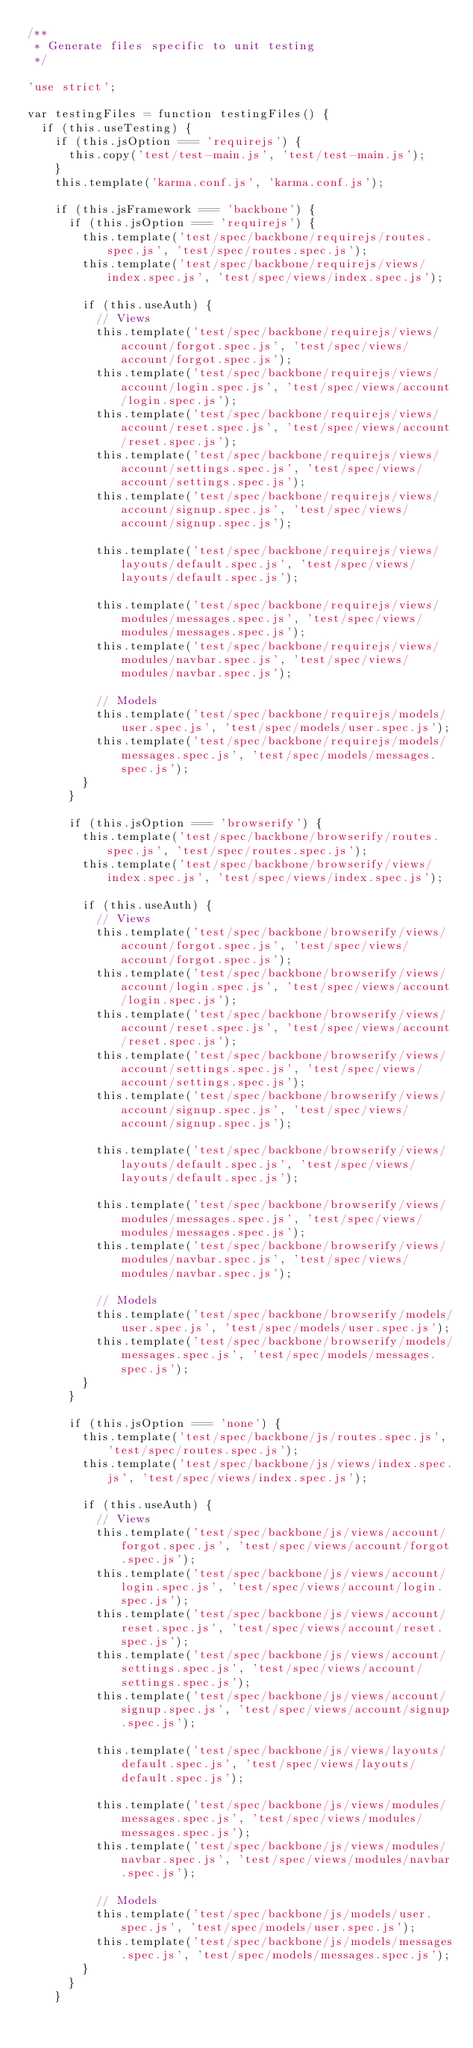<code> <loc_0><loc_0><loc_500><loc_500><_JavaScript_>/**
 * Generate files specific to unit testing
 */

'use strict';

var testingFiles = function testingFiles() {
  if (this.useTesting) {
    if (this.jsOption === 'requirejs') {
      this.copy('test/test-main.js', 'test/test-main.js');
    }
    this.template('karma.conf.js', 'karma.conf.js');

    if (this.jsFramework === 'backbone') {
      if (this.jsOption === 'requirejs') {
        this.template('test/spec/backbone/requirejs/routes.spec.js', 'test/spec/routes.spec.js');
        this.template('test/spec/backbone/requirejs/views/index.spec.js', 'test/spec/views/index.spec.js');

        if (this.useAuth) {
          // Views
          this.template('test/spec/backbone/requirejs/views/account/forgot.spec.js', 'test/spec/views/account/forgot.spec.js');
          this.template('test/spec/backbone/requirejs/views/account/login.spec.js', 'test/spec/views/account/login.spec.js');
          this.template('test/spec/backbone/requirejs/views/account/reset.spec.js', 'test/spec/views/account/reset.spec.js');
          this.template('test/spec/backbone/requirejs/views/account/settings.spec.js', 'test/spec/views/account/settings.spec.js');
          this.template('test/spec/backbone/requirejs/views/account/signup.spec.js', 'test/spec/views/account/signup.spec.js');

          this.template('test/spec/backbone/requirejs/views/layouts/default.spec.js', 'test/spec/views/layouts/default.spec.js');

          this.template('test/spec/backbone/requirejs/views/modules/messages.spec.js', 'test/spec/views/modules/messages.spec.js');
          this.template('test/spec/backbone/requirejs/views/modules/navbar.spec.js', 'test/spec/views/modules/navbar.spec.js');

          // Models
          this.template('test/spec/backbone/requirejs/models/user.spec.js', 'test/spec/models/user.spec.js');
          this.template('test/spec/backbone/requirejs/models/messages.spec.js', 'test/spec/models/messages.spec.js');
        }
      }

      if (this.jsOption === 'browserify') {
        this.template('test/spec/backbone/browserify/routes.spec.js', 'test/spec/routes.spec.js');
        this.template('test/spec/backbone/browserify/views/index.spec.js', 'test/spec/views/index.spec.js');

        if (this.useAuth) {
          // Views
          this.template('test/spec/backbone/browserify/views/account/forgot.spec.js', 'test/spec/views/account/forgot.spec.js');
          this.template('test/spec/backbone/browserify/views/account/login.spec.js', 'test/spec/views/account/login.spec.js');
          this.template('test/spec/backbone/browserify/views/account/reset.spec.js', 'test/spec/views/account/reset.spec.js');
          this.template('test/spec/backbone/browserify/views/account/settings.spec.js', 'test/spec/views/account/settings.spec.js');
          this.template('test/spec/backbone/browserify/views/account/signup.spec.js', 'test/spec/views/account/signup.spec.js');

          this.template('test/spec/backbone/browserify/views/layouts/default.spec.js', 'test/spec/views/layouts/default.spec.js');

          this.template('test/spec/backbone/browserify/views/modules/messages.spec.js', 'test/spec/views/modules/messages.spec.js');
          this.template('test/spec/backbone/browserify/views/modules/navbar.spec.js', 'test/spec/views/modules/navbar.spec.js');

          // Models
          this.template('test/spec/backbone/browserify/models/user.spec.js', 'test/spec/models/user.spec.js');
          this.template('test/spec/backbone/browserify/models/messages.spec.js', 'test/spec/models/messages.spec.js');
        }
      }

      if (this.jsOption === 'none') {
        this.template('test/spec/backbone/js/routes.spec.js', 'test/spec/routes.spec.js');
        this.template('test/spec/backbone/js/views/index.spec.js', 'test/spec/views/index.spec.js');

        if (this.useAuth) {
          // Views
          this.template('test/spec/backbone/js/views/account/forgot.spec.js', 'test/spec/views/account/forgot.spec.js');
          this.template('test/spec/backbone/js/views/account/login.spec.js', 'test/spec/views/account/login.spec.js');
          this.template('test/spec/backbone/js/views/account/reset.spec.js', 'test/spec/views/account/reset.spec.js');
          this.template('test/spec/backbone/js/views/account/settings.spec.js', 'test/spec/views/account/settings.spec.js');
          this.template('test/spec/backbone/js/views/account/signup.spec.js', 'test/spec/views/account/signup.spec.js');

          this.template('test/spec/backbone/js/views/layouts/default.spec.js', 'test/spec/views/layouts/default.spec.js');

          this.template('test/spec/backbone/js/views/modules/messages.spec.js', 'test/spec/views/modules/messages.spec.js');
          this.template('test/spec/backbone/js/views/modules/navbar.spec.js', 'test/spec/views/modules/navbar.spec.js');

          // Models
          this.template('test/spec/backbone/js/models/user.spec.js', 'test/spec/models/user.spec.js');
          this.template('test/spec/backbone/js/models/messages.spec.js', 'test/spec/models/messages.spec.js');
        }
      }
    }</code> 